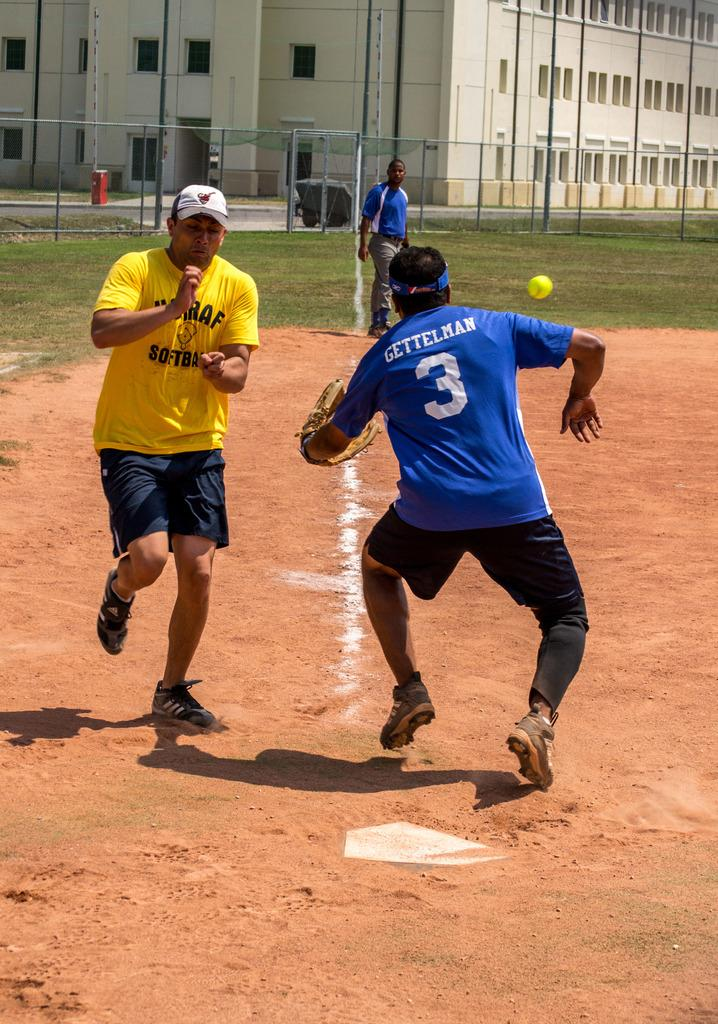What is the man on the left side of the image doing? The man on the left side of the image is running. What color is the t-shirt the man on the left side is wearing? The man on the left side is wearing a yellow t-shirt. What is the person on the right side of the image doing? The person on the right side of the image is also running. What color is the t-shirt the person on the right side is wearing? The person on the right side is wearing a blue t-shirt. What structure can be seen in the image? There is a building in the image. What type of pot is being used to whistle in the image? There is no pot or whistling activity present in the image. 